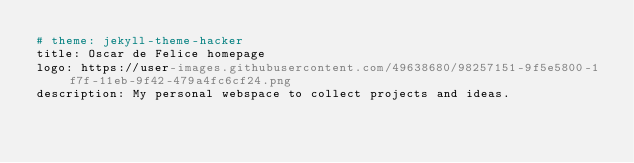Convert code to text. <code><loc_0><loc_0><loc_500><loc_500><_YAML_># theme: jekyll-theme-hacker
title: Oscar de Felice homepage
logo: https://user-images.githubusercontent.com/49638680/98257151-9f5e5800-1f7f-11eb-9f42-479a4fc6cf24.png
description: My personal webspace to collect projects and ideas.
</code> 